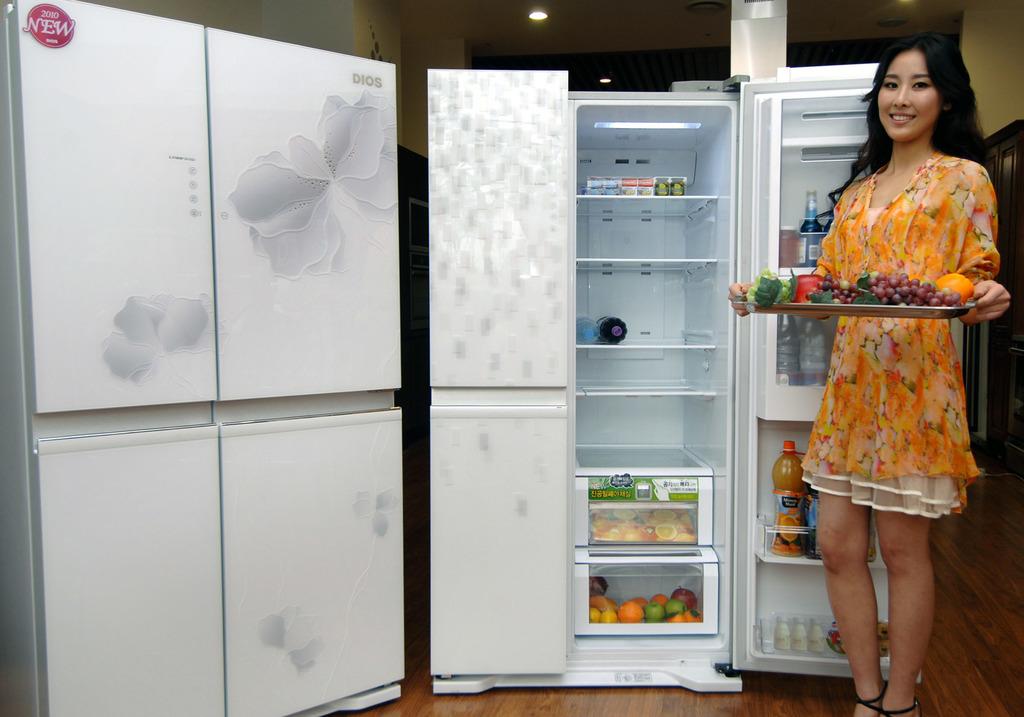What brand is that orange juice?
Your response must be concise. Minute maid. What does the logo say the very top left?
Ensure brevity in your answer.  New. 